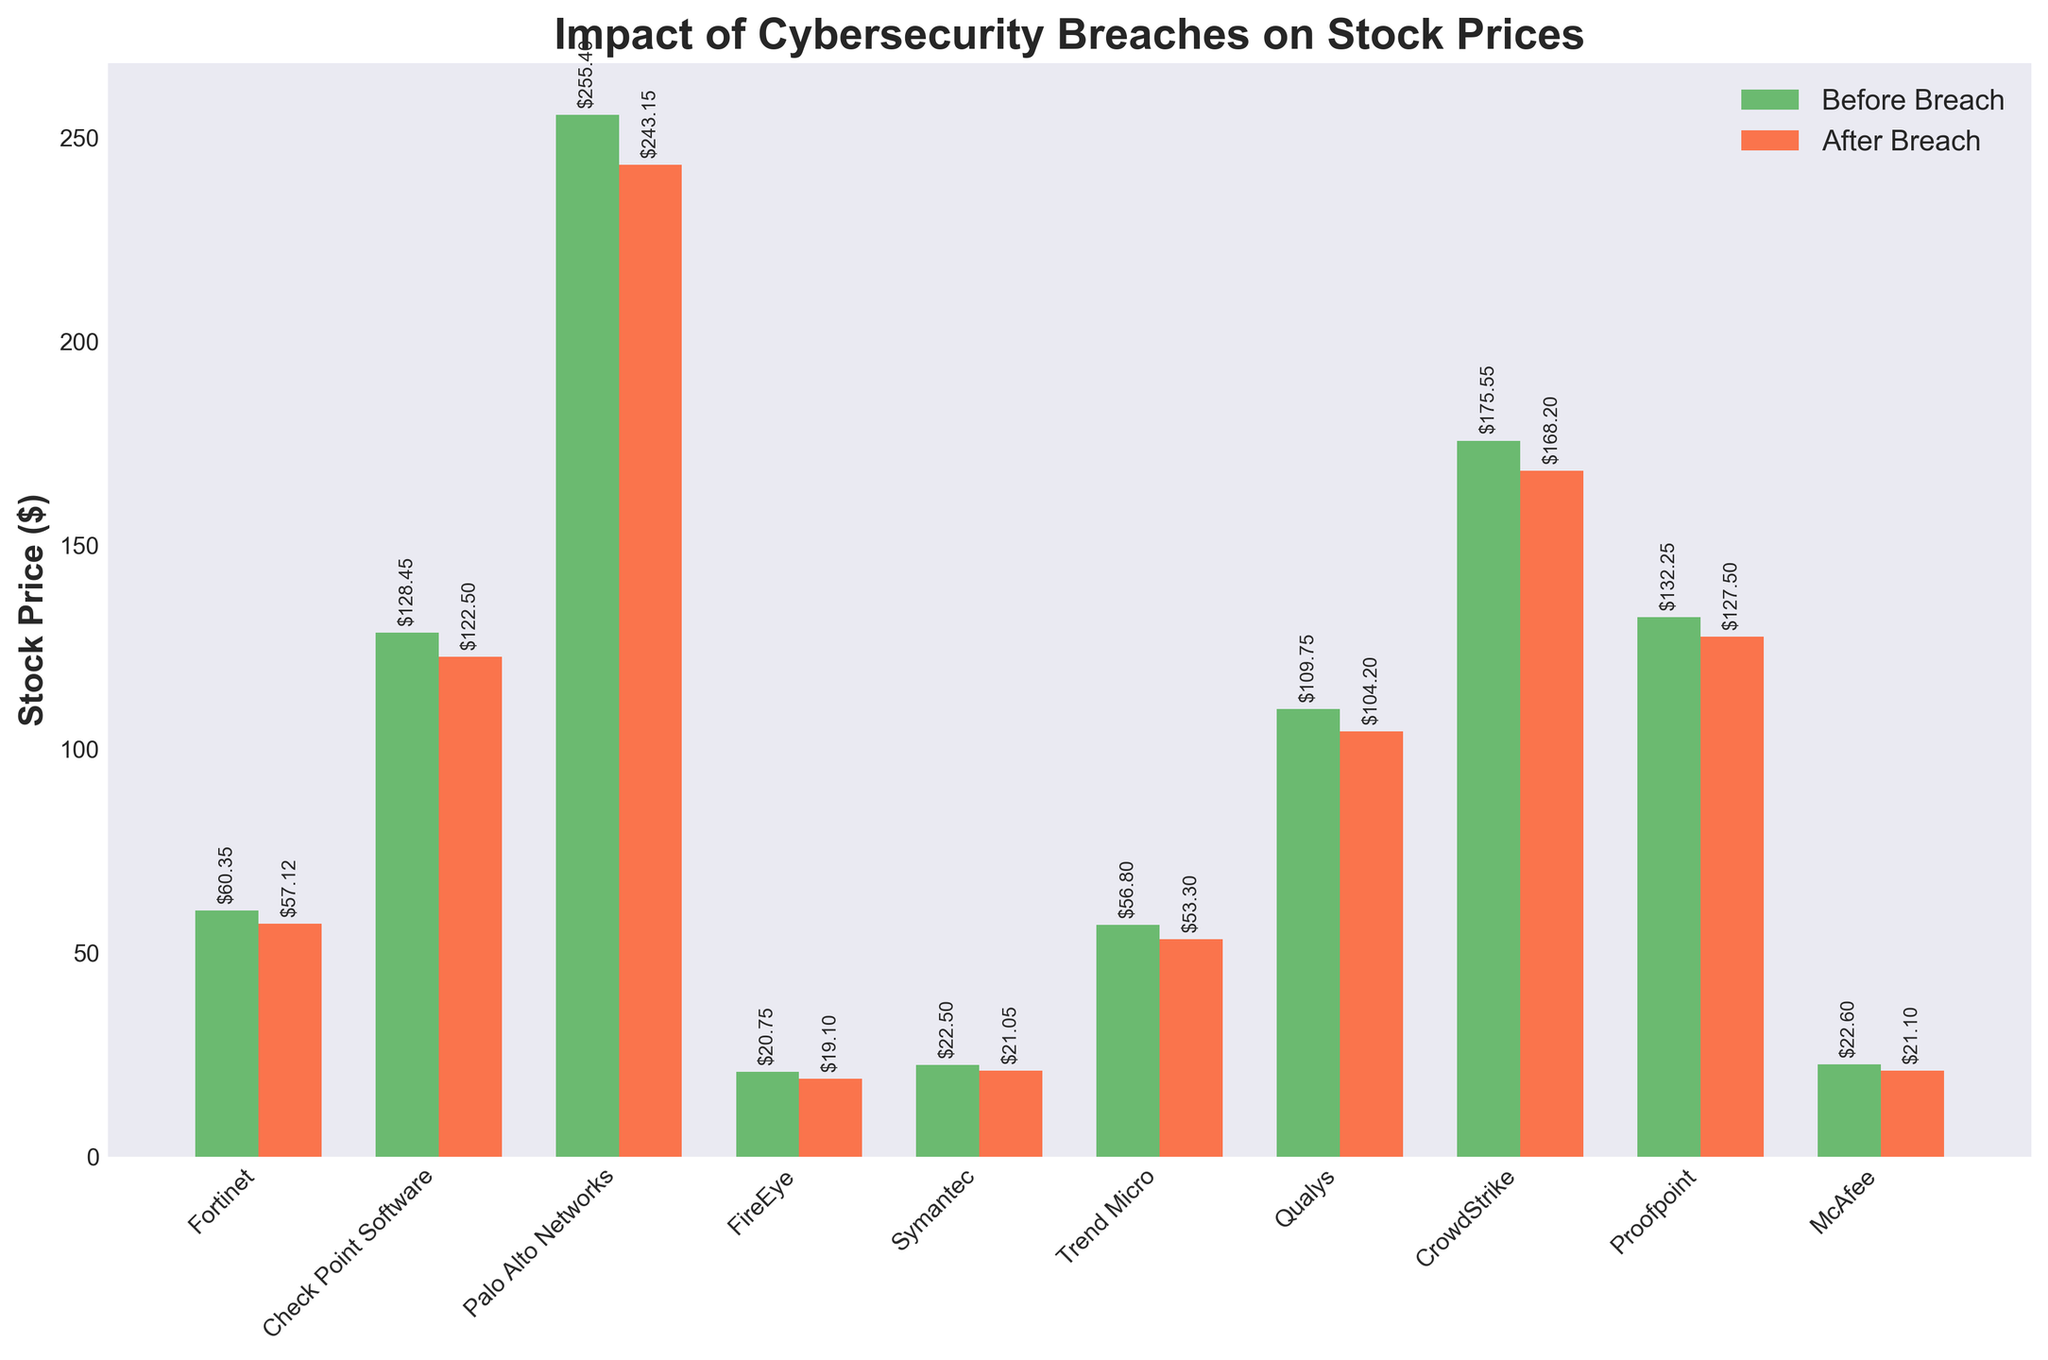What is the title of the plot? The title of the plot is positioned at the top and states: 'Impact of Cybersecurity Breaches on Stock Prices'.
Answer: Impact of Cybersecurity Breaches on Stock Prices Which company had the highest stock price before the breach? Looking at the green bars representing stock prices before the breach, we see that Palo Alto Networks had the highest stock price.
Answer: Palo Alto Networks What is the difference in stock price for Qualys before and after the breach? Qualys' stock price before the breach was $109.75, and after the breach, it was $104.20. To find the difference, we subtract the after price from the before price: $109.75 - $104.20 = $5.55.
Answer: $5.55 Which company's stock price decreased the most after the breach? By observing the height differences between the green (before) and orange (after) bars, Palo Alto Networks shows the largest drop. Calculating the difference: $255.40 - $243.15 = $12.25.
Answer: Palo Alto Networks What is the stock price of McAfee after the breach? McAfee’s stock price after the breach is shown by the orange bar, which is labeled as $21.10.
Answer: $21.10 Calculate the average stock price after the breach for the listed companies. Summing up the stock prices after the breach for all companies: $57.12 + $122.50 + $243.15 + $19.10 + $21.05 + $53.30 + $104.20 + $168.20 + $127.50 + $21.10 = $937.22. Dividing by the number of companies, which is 10: $937.22 / 10 = $93.72.
Answer: $93.72 Which company experienced the smallest percentage decrease in stock price after the breach? To find the smallest percentage decrease, calculate the percentage drop for each company, then compare them. For example, for Symantec: (($22.50 - $21.05)/$22.50)*100 = 6.44%. Perform similar calculations for all companies and compare. Symantec has the smallest.
Answer: Symantec Which two companies had a similar stock price after the breach? Observing the orange bars, we note that Symantec and McAfee both had stock prices close to $21 after the breach: Symantec at $21.05 and McAfee at $21.10.
Answer: Symantec and McAfee How many companies are included in this plot? Count the number of distinct labels on the x-axis representing companies. There are 10 companies listed.
Answer: 10 What is the median stock price after the breach for the listed companies? Arrange the stock prices after the breach in ascending order: $19.10, $21.05, $21.10, $53.30, $57.12, $104.20, $122.50, $127.50, $168.20, $243.15. The middle values are $57.12 and $104.20, so, the median is the average of these two values: ($57.12 + $104.20) / 2 = $80.66.
Answer: $80.66 